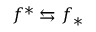Convert formula to latex. <formula><loc_0><loc_0><loc_500><loc_500>f ^ { * } \leftrightarrow s f _ { * }</formula> 